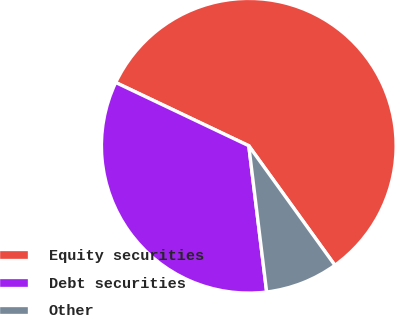Convert chart to OTSL. <chart><loc_0><loc_0><loc_500><loc_500><pie_chart><fcel>Equity securities<fcel>Debt securities<fcel>Other<nl><fcel>58.0%<fcel>34.0%<fcel>8.0%<nl></chart> 